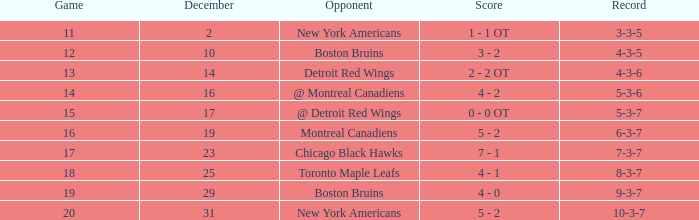Which Score has a December smaller than 14, and a Game of 12? 3 - 2. 